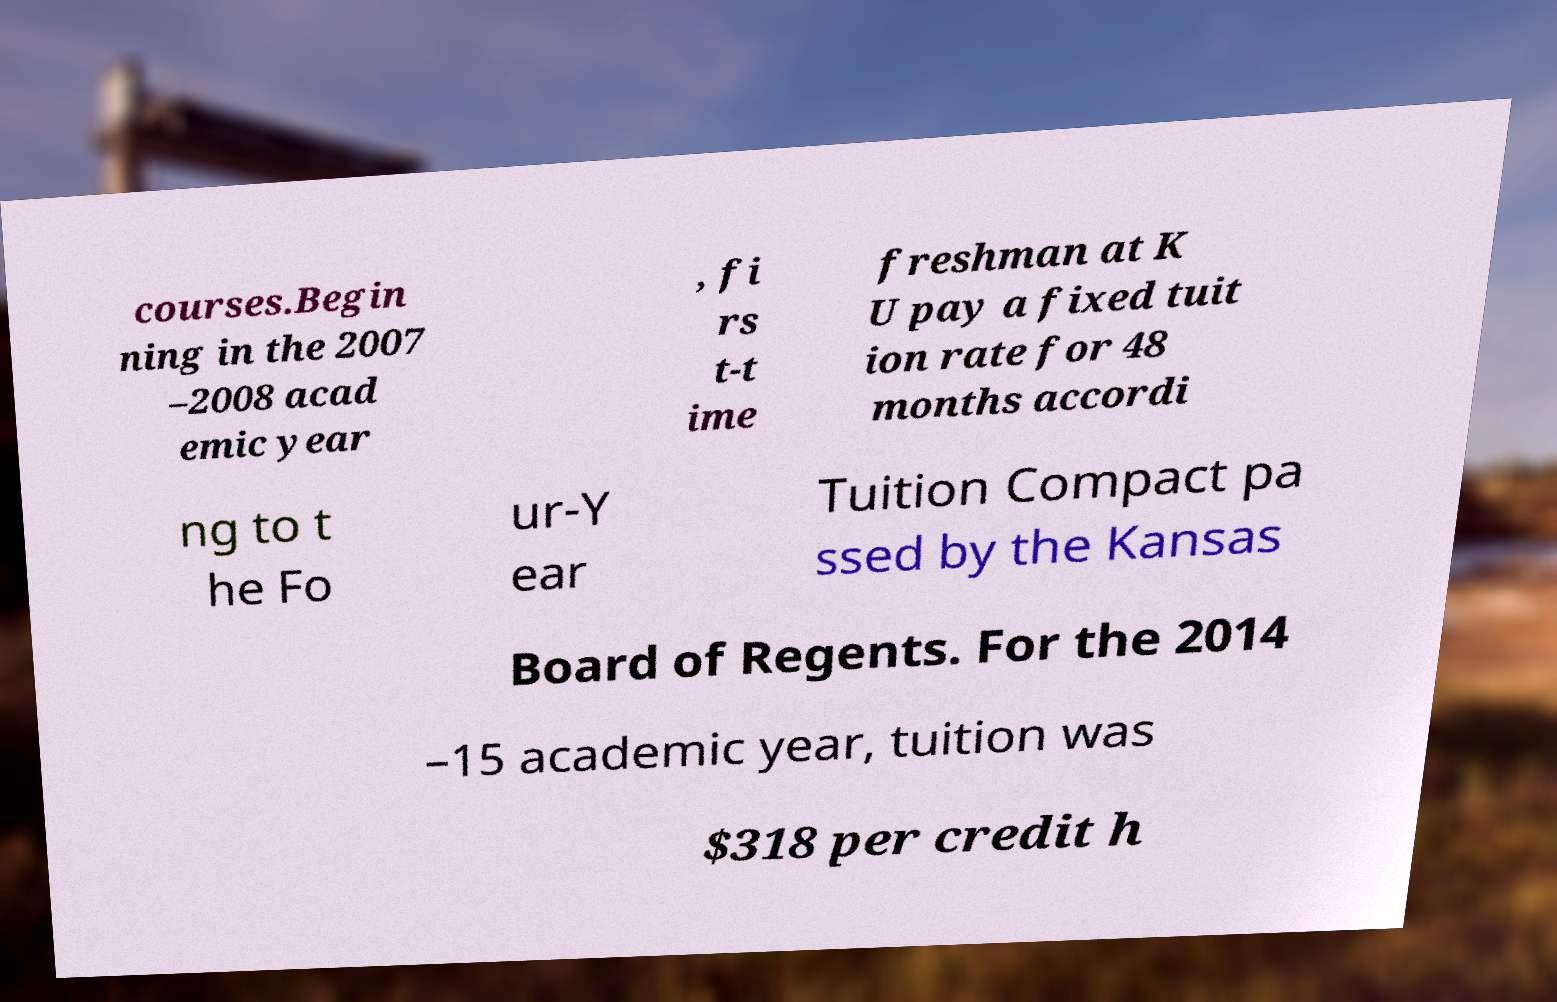Could you assist in decoding the text presented in this image and type it out clearly? courses.Begin ning in the 2007 –2008 acad emic year , fi rs t-t ime freshman at K U pay a fixed tuit ion rate for 48 months accordi ng to t he Fo ur-Y ear Tuition Compact pa ssed by the Kansas Board of Regents. For the 2014 –15 academic year, tuition was $318 per credit h 